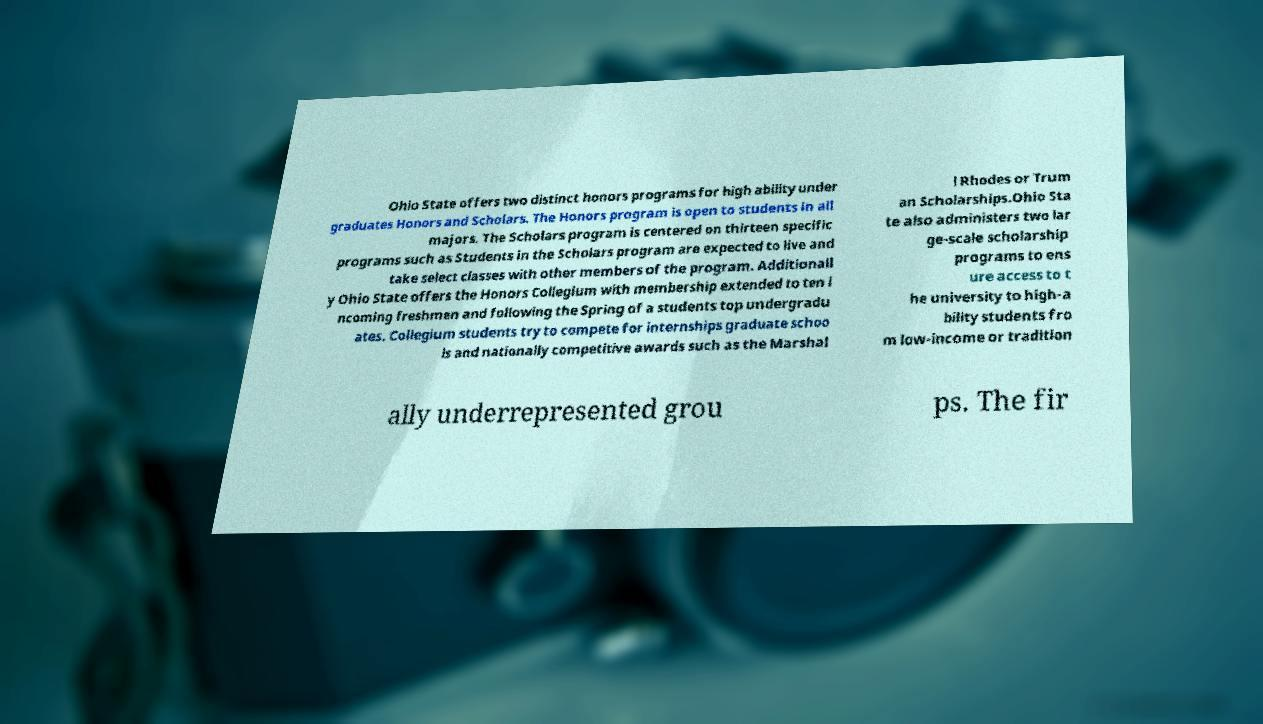For documentation purposes, I need the text within this image transcribed. Could you provide that? Ohio State offers two distinct honors programs for high ability under graduates Honors and Scholars. The Honors program is open to students in all majors. The Scholars program is centered on thirteen specific programs such as Students in the Scholars program are expected to live and take select classes with other members of the program. Additionall y Ohio State offers the Honors Collegium with membership extended to ten i ncoming freshmen and following the Spring of a students top undergradu ates. Collegium students try to compete for internships graduate schoo ls and nationally competitive awards such as the Marshal l Rhodes or Trum an Scholarships.Ohio Sta te also administers two lar ge-scale scholarship programs to ens ure access to t he university to high-a bility students fro m low-income or tradition ally underrepresented grou ps. The fir 